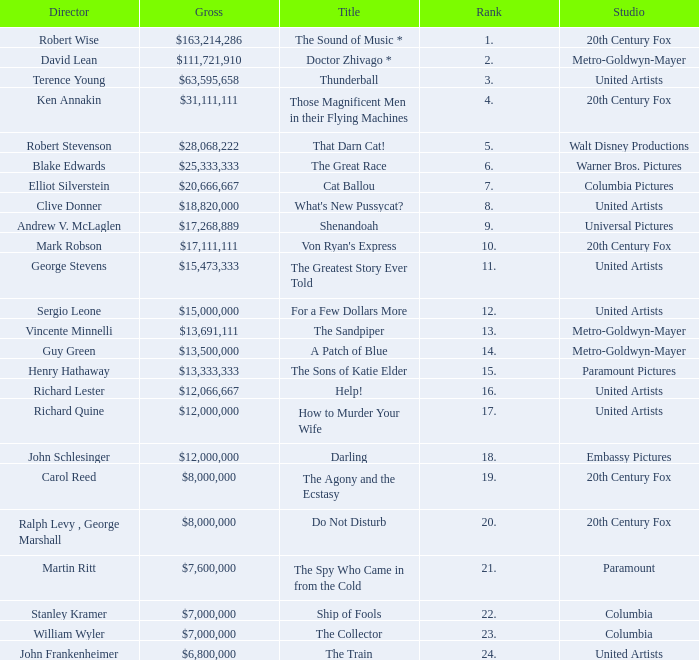What is Title, when Studio is "Embassy Pictures"? Darling. Would you mind parsing the complete table? {'header': ['Director', 'Gross', 'Title', 'Rank', 'Studio'], 'rows': [['Robert Wise', '$163,214,286', 'The Sound of Music *', '1.', '20th Century Fox'], ['David Lean', '$111,721,910', 'Doctor Zhivago *', '2.', 'Metro-Goldwyn-Mayer'], ['Terence Young', '$63,595,658', 'Thunderball', '3.', 'United Artists'], ['Ken Annakin', '$31,111,111', 'Those Magnificent Men in their Flying Machines', '4.', '20th Century Fox'], ['Robert Stevenson', '$28,068,222', 'That Darn Cat!', '5.', 'Walt Disney Productions'], ['Blake Edwards', '$25,333,333', 'The Great Race', '6.', 'Warner Bros. Pictures'], ['Elliot Silverstein', '$20,666,667', 'Cat Ballou', '7.', 'Columbia Pictures'], ['Clive Donner', '$18,820,000', "What's New Pussycat?", '8.', 'United Artists'], ['Andrew V. McLaglen', '$17,268,889', 'Shenandoah', '9.', 'Universal Pictures'], ['Mark Robson', '$17,111,111', "Von Ryan's Express", '10.', '20th Century Fox'], ['George Stevens', '$15,473,333', 'The Greatest Story Ever Told', '11.', 'United Artists'], ['Sergio Leone', '$15,000,000', 'For a Few Dollars More', '12.', 'United Artists'], ['Vincente Minnelli', '$13,691,111', 'The Sandpiper', '13.', 'Metro-Goldwyn-Mayer'], ['Guy Green', '$13,500,000', 'A Patch of Blue', '14.', 'Metro-Goldwyn-Mayer'], ['Henry Hathaway', '$13,333,333', 'The Sons of Katie Elder', '15.', 'Paramount Pictures'], ['Richard Lester', '$12,066,667', 'Help!', '16.', 'United Artists'], ['Richard Quine', '$12,000,000', 'How to Murder Your Wife', '17.', 'United Artists'], ['John Schlesinger', '$12,000,000', 'Darling', '18.', 'Embassy Pictures'], ['Carol Reed', '$8,000,000', 'The Agony and the Ecstasy', '19.', '20th Century Fox'], ['Ralph Levy , George Marshall', '$8,000,000', 'Do Not Disturb', '20.', '20th Century Fox'], ['Martin Ritt', '$7,600,000', 'The Spy Who Came in from the Cold', '21.', 'Paramount'], ['Stanley Kramer', '$7,000,000', 'Ship of Fools', '22.', 'Columbia'], ['William Wyler', '$7,000,000', 'The Collector', '23.', 'Columbia'], ['John Frankenheimer', '$6,800,000', 'The Train', '24.', 'United Artists']]} 